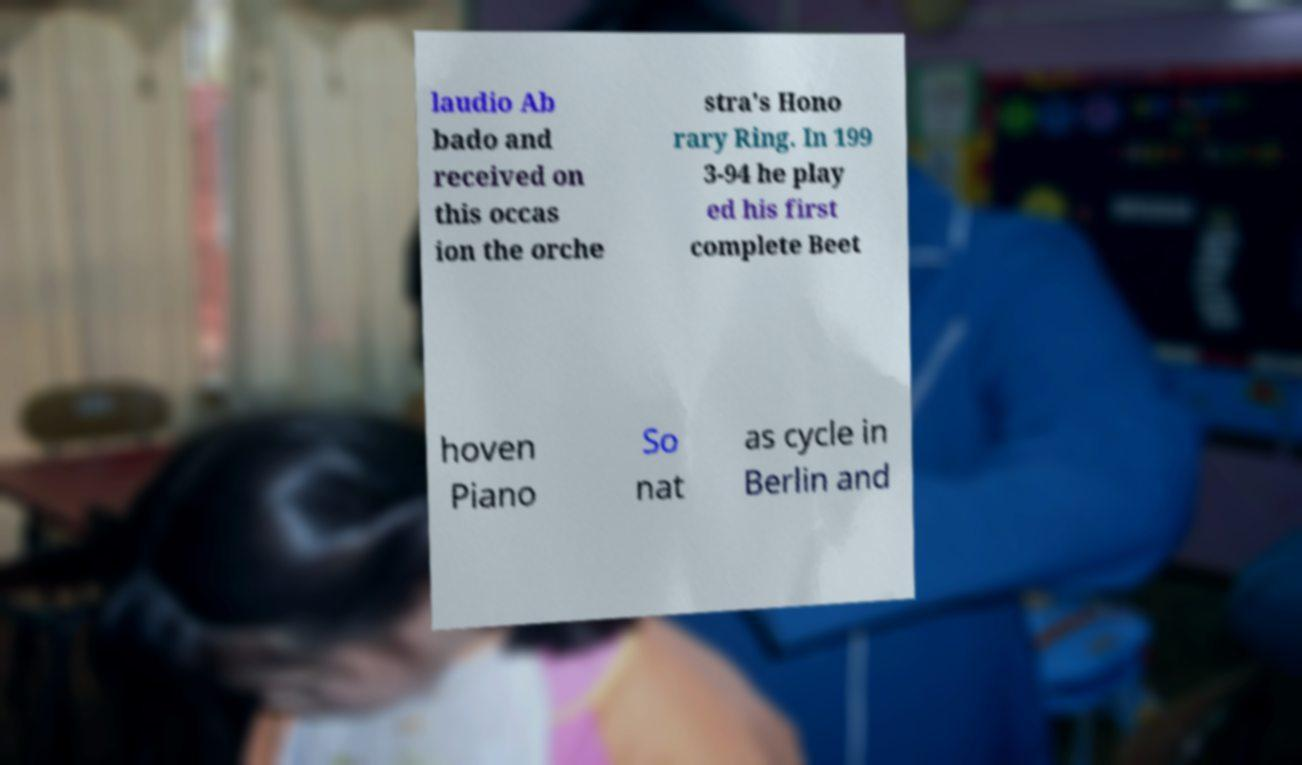Can you accurately transcribe the text from the provided image for me? laudio Ab bado and received on this occas ion the orche stra's Hono rary Ring. In 199 3-94 he play ed his first complete Beet hoven Piano So nat as cycle in Berlin and 